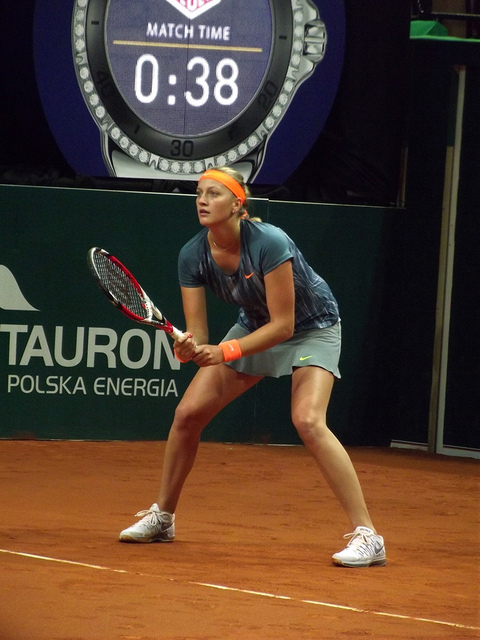Identify the text contained in this image. TAURON POLSKA ENERGIA MATCH TIME 38 0 20 30 